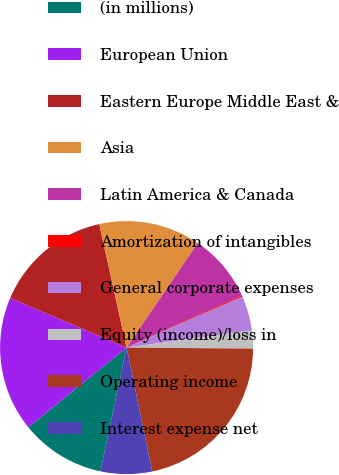Convert chart. <chart><loc_0><loc_0><loc_500><loc_500><pie_chart><fcel>(in millions)<fcel>European Union<fcel>Eastern Europe Middle East &<fcel>Asia<fcel>Latin America & Canada<fcel>Amortization of intangibles<fcel>General corporate expenses<fcel>Equity (income)/loss in<fcel>Operating income<fcel>Interest expense net<nl><fcel>10.84%<fcel>17.25%<fcel>15.12%<fcel>12.98%<fcel>8.71%<fcel>0.17%<fcel>4.44%<fcel>2.3%<fcel>21.62%<fcel>6.57%<nl></chart> 